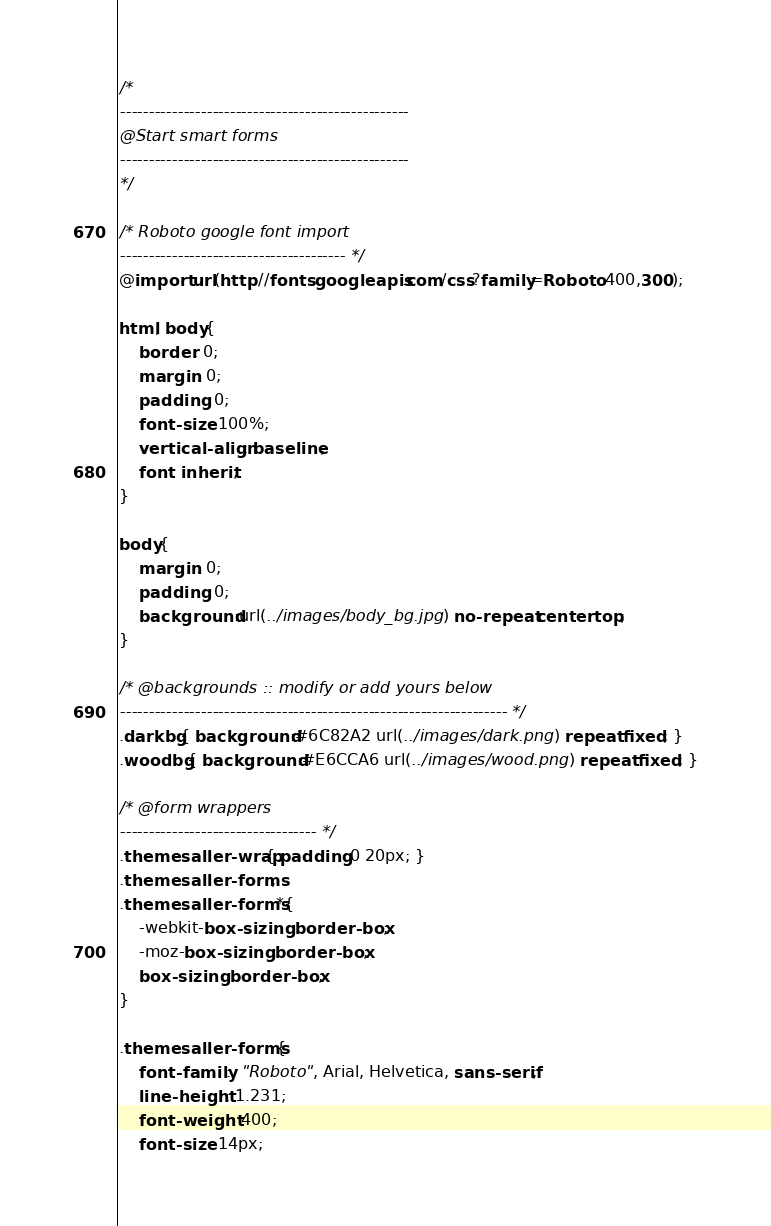<code> <loc_0><loc_0><loc_500><loc_500><_CSS_>
/*	
--------------------------------------------------
@Start smart forms
-------------------------------------------------- 
*/

/* Roboto google font import 
--------------------------------------- */
@import url(http://fonts.googleapis.com/css?family=Roboto:400,300);

html, body{
	border: 0;
	margin: 0;
	padding: 0;
	font-size: 100%;
	vertical-align: baseline; 
	font: inherit;
}

body{
	margin: 0;
	padding: 0;
	background:url(../images/body_bg.jpg) no-repeat center top;
}

/* @backgrounds :: modify or add yours below 
------------------------------------------------------------------- */
.darkbg{ background:#6C82A2 url(../images/dark.png) repeat fixed; }
.woodbg{ background:#E6CCA6 url(../images/wood.png) repeat fixed; }

/* @form wrappers 
---------------------------------- */
.themesaller-wrap{ padding:0 20px; }
.themesaller-forms, 
.themesaller-forms *{
	-webkit-box-sizing: border-box;
	-moz-box-sizing: border-box;
	box-sizing: border-box;
}

.themesaller-forms {
	font-family:  "Roboto", Arial, Helvetica, sans-serif;
	line-height: 1.231;
	font-weight: 400;
	font-size: 14px;</code> 